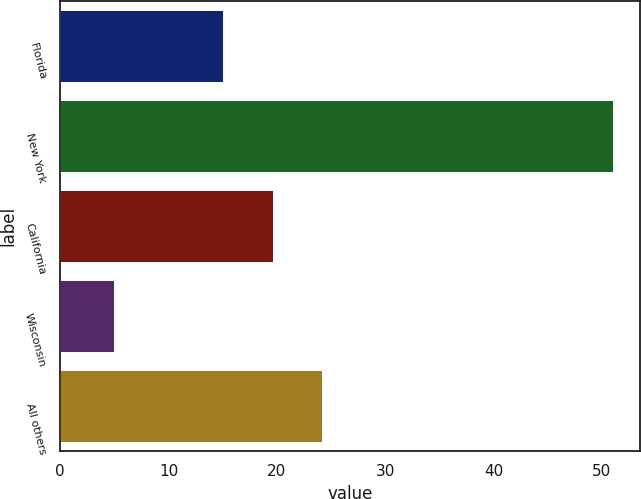Convert chart to OTSL. <chart><loc_0><loc_0><loc_500><loc_500><bar_chart><fcel>Florida<fcel>New York<fcel>California<fcel>Wisconsin<fcel>All others<nl><fcel>15<fcel>51<fcel>19.6<fcel>5<fcel>24.2<nl></chart> 